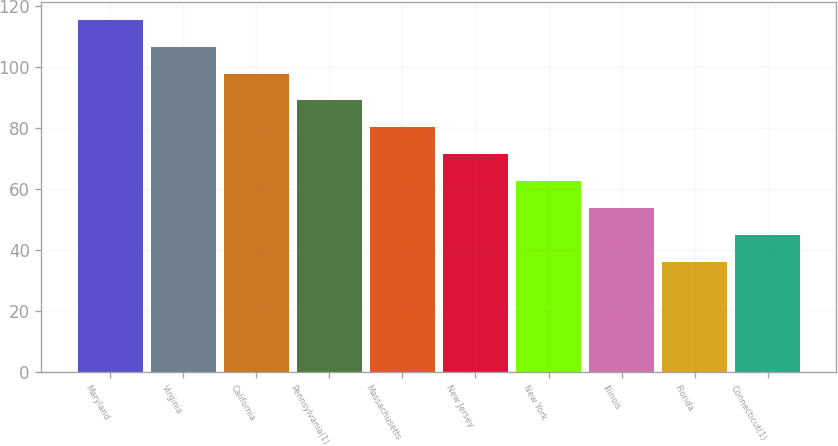Convert chart to OTSL. <chart><loc_0><loc_0><loc_500><loc_500><bar_chart><fcel>Maryland<fcel>Virginia<fcel>California<fcel>Pennsylvania(1)<fcel>Massachusetts<fcel>New Jersey<fcel>New York<fcel>Illinois<fcel>Florida<fcel>Connecticut(1)<nl><fcel>115.4<fcel>106.6<fcel>97.8<fcel>89<fcel>80.2<fcel>71.4<fcel>62.6<fcel>53.8<fcel>36.2<fcel>45<nl></chart> 